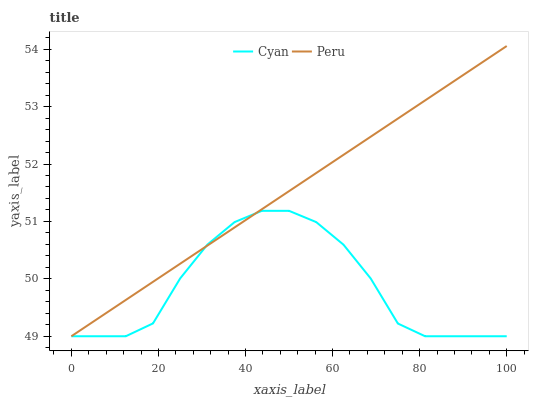Does Peru have the minimum area under the curve?
Answer yes or no. No. Is Peru the roughest?
Answer yes or no. No. 